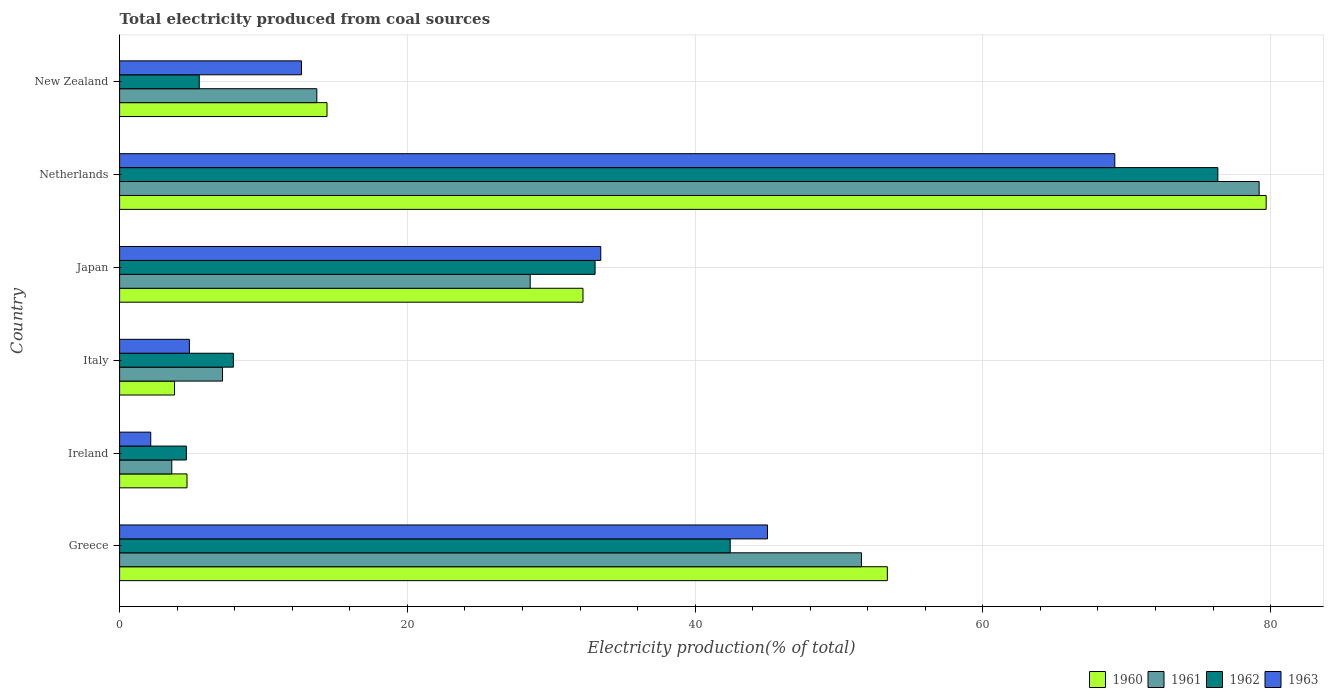Are the number of bars per tick equal to the number of legend labels?
Keep it short and to the point. Yes. How many bars are there on the 2nd tick from the top?
Your answer should be compact. 4. How many bars are there on the 5th tick from the bottom?
Offer a very short reply. 4. What is the total electricity produced in 1961 in New Zealand?
Offer a very short reply. 13.71. Across all countries, what is the maximum total electricity produced in 1963?
Give a very brief answer. 69.17. Across all countries, what is the minimum total electricity produced in 1962?
Give a very brief answer. 4.64. In which country was the total electricity produced in 1963 maximum?
Your response must be concise. Netherlands. In which country was the total electricity produced in 1963 minimum?
Make the answer very short. Ireland. What is the total total electricity produced in 1961 in the graph?
Provide a succinct answer. 183.8. What is the difference between the total electricity produced in 1963 in Italy and that in Japan?
Offer a terse response. -28.59. What is the difference between the total electricity produced in 1960 in Greece and the total electricity produced in 1963 in Netherlands?
Ensure brevity in your answer.  -15.81. What is the average total electricity produced in 1962 per country?
Your answer should be very brief. 28.32. What is the difference between the total electricity produced in 1962 and total electricity produced in 1960 in Japan?
Make the answer very short. 0.84. In how many countries, is the total electricity produced in 1961 greater than 8 %?
Keep it short and to the point. 4. What is the ratio of the total electricity produced in 1963 in Italy to that in New Zealand?
Keep it short and to the point. 0.38. Is the total electricity produced in 1962 in Italy less than that in New Zealand?
Ensure brevity in your answer.  No. Is the difference between the total electricity produced in 1962 in Greece and Japan greater than the difference between the total electricity produced in 1960 in Greece and Japan?
Provide a succinct answer. No. What is the difference between the highest and the second highest total electricity produced in 1961?
Your response must be concise. 27.64. What is the difference between the highest and the lowest total electricity produced in 1962?
Your response must be concise. 71.69. In how many countries, is the total electricity produced in 1963 greater than the average total electricity produced in 1963 taken over all countries?
Provide a succinct answer. 3. What does the 2nd bar from the top in New Zealand represents?
Offer a terse response. 1962. What does the 3rd bar from the bottom in Ireland represents?
Provide a succinct answer. 1962. How many bars are there?
Ensure brevity in your answer.  24. Are all the bars in the graph horizontal?
Your answer should be compact. Yes. How many countries are there in the graph?
Give a very brief answer. 6. Are the values on the major ticks of X-axis written in scientific E-notation?
Ensure brevity in your answer.  No. Does the graph contain any zero values?
Your response must be concise. No. Does the graph contain grids?
Your answer should be very brief. Yes. Where does the legend appear in the graph?
Your answer should be compact. Bottom right. How many legend labels are there?
Your answer should be compact. 4. How are the legend labels stacked?
Offer a very short reply. Horizontal. What is the title of the graph?
Make the answer very short. Total electricity produced from coal sources. Does "2010" appear as one of the legend labels in the graph?
Your response must be concise. No. What is the Electricity production(% of total) of 1960 in Greece?
Provide a short and direct response. 53.36. What is the Electricity production(% of total) of 1961 in Greece?
Your response must be concise. 51.56. What is the Electricity production(% of total) of 1962 in Greece?
Make the answer very short. 42.44. What is the Electricity production(% of total) of 1963 in Greece?
Offer a very short reply. 45.03. What is the Electricity production(% of total) of 1960 in Ireland?
Make the answer very short. 4.69. What is the Electricity production(% of total) in 1961 in Ireland?
Offer a very short reply. 3.63. What is the Electricity production(% of total) of 1962 in Ireland?
Offer a terse response. 4.64. What is the Electricity production(% of total) of 1963 in Ireland?
Keep it short and to the point. 2.16. What is the Electricity production(% of total) of 1960 in Italy?
Provide a succinct answer. 3.82. What is the Electricity production(% of total) of 1961 in Italy?
Provide a short and direct response. 7.15. What is the Electricity production(% of total) in 1962 in Italy?
Your answer should be compact. 7.91. What is the Electricity production(% of total) of 1963 in Italy?
Your response must be concise. 4.85. What is the Electricity production(% of total) of 1960 in Japan?
Your answer should be compact. 32.21. What is the Electricity production(% of total) in 1961 in Japan?
Your answer should be compact. 28.54. What is the Electricity production(% of total) in 1962 in Japan?
Offer a very short reply. 33.05. What is the Electricity production(% of total) in 1963 in Japan?
Offer a terse response. 33.44. What is the Electricity production(% of total) in 1960 in Netherlands?
Your answer should be very brief. 79.69. What is the Electricity production(% of total) of 1961 in Netherlands?
Provide a succinct answer. 79.2. What is the Electricity production(% of total) in 1962 in Netherlands?
Ensure brevity in your answer.  76.33. What is the Electricity production(% of total) in 1963 in Netherlands?
Ensure brevity in your answer.  69.17. What is the Electricity production(% of total) in 1960 in New Zealand?
Your answer should be very brief. 14.42. What is the Electricity production(% of total) of 1961 in New Zealand?
Keep it short and to the point. 13.71. What is the Electricity production(% of total) of 1962 in New Zealand?
Your answer should be compact. 5.54. What is the Electricity production(% of total) of 1963 in New Zealand?
Your answer should be compact. 12.64. Across all countries, what is the maximum Electricity production(% of total) of 1960?
Make the answer very short. 79.69. Across all countries, what is the maximum Electricity production(% of total) of 1961?
Provide a short and direct response. 79.2. Across all countries, what is the maximum Electricity production(% of total) in 1962?
Give a very brief answer. 76.33. Across all countries, what is the maximum Electricity production(% of total) of 1963?
Offer a very short reply. 69.17. Across all countries, what is the minimum Electricity production(% of total) of 1960?
Your response must be concise. 3.82. Across all countries, what is the minimum Electricity production(% of total) in 1961?
Ensure brevity in your answer.  3.63. Across all countries, what is the minimum Electricity production(% of total) in 1962?
Make the answer very short. 4.64. Across all countries, what is the minimum Electricity production(% of total) in 1963?
Your response must be concise. 2.16. What is the total Electricity production(% of total) in 1960 in the graph?
Your answer should be very brief. 188.18. What is the total Electricity production(% of total) in 1961 in the graph?
Your response must be concise. 183.8. What is the total Electricity production(% of total) of 1962 in the graph?
Offer a terse response. 169.91. What is the total Electricity production(% of total) in 1963 in the graph?
Provide a succinct answer. 167.3. What is the difference between the Electricity production(% of total) in 1960 in Greece and that in Ireland?
Provide a succinct answer. 48.68. What is the difference between the Electricity production(% of total) in 1961 in Greece and that in Ireland?
Your response must be concise. 47.93. What is the difference between the Electricity production(% of total) in 1962 in Greece and that in Ireland?
Your answer should be very brief. 37.8. What is the difference between the Electricity production(% of total) in 1963 in Greece and that in Ireland?
Keep it short and to the point. 42.87. What is the difference between the Electricity production(% of total) of 1960 in Greece and that in Italy?
Provide a succinct answer. 49.54. What is the difference between the Electricity production(% of total) in 1961 in Greece and that in Italy?
Ensure brevity in your answer.  44.41. What is the difference between the Electricity production(% of total) of 1962 in Greece and that in Italy?
Make the answer very short. 34.53. What is the difference between the Electricity production(% of total) of 1963 in Greece and that in Italy?
Provide a short and direct response. 40.18. What is the difference between the Electricity production(% of total) of 1960 in Greece and that in Japan?
Give a very brief answer. 21.15. What is the difference between the Electricity production(% of total) in 1961 in Greece and that in Japan?
Provide a succinct answer. 23.02. What is the difference between the Electricity production(% of total) of 1962 in Greece and that in Japan?
Give a very brief answer. 9.39. What is the difference between the Electricity production(% of total) of 1963 in Greece and that in Japan?
Provide a short and direct response. 11.59. What is the difference between the Electricity production(% of total) of 1960 in Greece and that in Netherlands?
Keep it short and to the point. -26.33. What is the difference between the Electricity production(% of total) in 1961 in Greece and that in Netherlands?
Offer a terse response. -27.64. What is the difference between the Electricity production(% of total) of 1962 in Greece and that in Netherlands?
Your answer should be compact. -33.89. What is the difference between the Electricity production(% of total) in 1963 in Greece and that in Netherlands?
Your response must be concise. -24.14. What is the difference between the Electricity production(% of total) in 1960 in Greece and that in New Zealand?
Provide a succinct answer. 38.95. What is the difference between the Electricity production(% of total) of 1961 in Greece and that in New Zealand?
Provide a short and direct response. 37.85. What is the difference between the Electricity production(% of total) of 1962 in Greece and that in New Zealand?
Offer a terse response. 36.9. What is the difference between the Electricity production(% of total) in 1963 in Greece and that in New Zealand?
Ensure brevity in your answer.  32.39. What is the difference between the Electricity production(% of total) of 1960 in Ireland and that in Italy?
Make the answer very short. 0.87. What is the difference between the Electricity production(% of total) in 1961 in Ireland and that in Italy?
Keep it short and to the point. -3.53. What is the difference between the Electricity production(% of total) in 1962 in Ireland and that in Italy?
Offer a terse response. -3.27. What is the difference between the Electricity production(% of total) of 1963 in Ireland and that in Italy?
Offer a very short reply. -2.69. What is the difference between the Electricity production(% of total) of 1960 in Ireland and that in Japan?
Keep it short and to the point. -27.52. What is the difference between the Electricity production(% of total) in 1961 in Ireland and that in Japan?
Your answer should be very brief. -24.91. What is the difference between the Electricity production(% of total) in 1962 in Ireland and that in Japan?
Your answer should be very brief. -28.41. What is the difference between the Electricity production(% of total) in 1963 in Ireland and that in Japan?
Ensure brevity in your answer.  -31.28. What is the difference between the Electricity production(% of total) in 1960 in Ireland and that in Netherlands?
Your answer should be compact. -75.01. What is the difference between the Electricity production(% of total) of 1961 in Ireland and that in Netherlands?
Provide a short and direct response. -75.58. What is the difference between the Electricity production(% of total) in 1962 in Ireland and that in Netherlands?
Your answer should be compact. -71.69. What is the difference between the Electricity production(% of total) in 1963 in Ireland and that in Netherlands?
Give a very brief answer. -67.01. What is the difference between the Electricity production(% of total) in 1960 in Ireland and that in New Zealand?
Keep it short and to the point. -9.73. What is the difference between the Electricity production(% of total) in 1961 in Ireland and that in New Zealand?
Ensure brevity in your answer.  -10.08. What is the difference between the Electricity production(% of total) of 1962 in Ireland and that in New Zealand?
Provide a succinct answer. -0.9. What is the difference between the Electricity production(% of total) in 1963 in Ireland and that in New Zealand?
Make the answer very short. -10.48. What is the difference between the Electricity production(% of total) in 1960 in Italy and that in Japan?
Provide a succinct answer. -28.39. What is the difference between the Electricity production(% of total) in 1961 in Italy and that in Japan?
Provide a succinct answer. -21.38. What is the difference between the Electricity production(% of total) in 1962 in Italy and that in Japan?
Provide a succinct answer. -25.14. What is the difference between the Electricity production(% of total) of 1963 in Italy and that in Japan?
Make the answer very short. -28.59. What is the difference between the Electricity production(% of total) of 1960 in Italy and that in Netherlands?
Provide a succinct answer. -75.87. What is the difference between the Electricity production(% of total) in 1961 in Italy and that in Netherlands?
Keep it short and to the point. -72.05. What is the difference between the Electricity production(% of total) in 1962 in Italy and that in Netherlands?
Offer a very short reply. -68.42. What is the difference between the Electricity production(% of total) in 1963 in Italy and that in Netherlands?
Offer a terse response. -64.32. What is the difference between the Electricity production(% of total) of 1960 in Italy and that in New Zealand?
Your answer should be very brief. -10.6. What is the difference between the Electricity production(% of total) of 1961 in Italy and that in New Zealand?
Provide a short and direct response. -6.55. What is the difference between the Electricity production(% of total) of 1962 in Italy and that in New Zealand?
Offer a very short reply. 2.37. What is the difference between the Electricity production(% of total) of 1963 in Italy and that in New Zealand?
Keep it short and to the point. -7.79. What is the difference between the Electricity production(% of total) of 1960 in Japan and that in Netherlands?
Provide a succinct answer. -47.48. What is the difference between the Electricity production(% of total) in 1961 in Japan and that in Netherlands?
Ensure brevity in your answer.  -50.67. What is the difference between the Electricity production(% of total) of 1962 in Japan and that in Netherlands?
Ensure brevity in your answer.  -43.28. What is the difference between the Electricity production(% of total) of 1963 in Japan and that in Netherlands?
Ensure brevity in your answer.  -35.73. What is the difference between the Electricity production(% of total) in 1960 in Japan and that in New Zealand?
Your answer should be compact. 17.79. What is the difference between the Electricity production(% of total) of 1961 in Japan and that in New Zealand?
Your answer should be compact. 14.83. What is the difference between the Electricity production(% of total) of 1962 in Japan and that in New Zealand?
Give a very brief answer. 27.51. What is the difference between the Electricity production(% of total) of 1963 in Japan and that in New Zealand?
Keep it short and to the point. 20.8. What is the difference between the Electricity production(% of total) of 1960 in Netherlands and that in New Zealand?
Offer a very short reply. 65.28. What is the difference between the Electricity production(% of total) of 1961 in Netherlands and that in New Zealand?
Provide a short and direct response. 65.5. What is the difference between the Electricity production(% of total) of 1962 in Netherlands and that in New Zealand?
Keep it short and to the point. 70.8. What is the difference between the Electricity production(% of total) in 1963 in Netherlands and that in New Zealand?
Ensure brevity in your answer.  56.53. What is the difference between the Electricity production(% of total) in 1960 in Greece and the Electricity production(% of total) in 1961 in Ireland?
Your answer should be very brief. 49.73. What is the difference between the Electricity production(% of total) of 1960 in Greece and the Electricity production(% of total) of 1962 in Ireland?
Provide a short and direct response. 48.72. What is the difference between the Electricity production(% of total) in 1960 in Greece and the Electricity production(% of total) in 1963 in Ireland?
Provide a short and direct response. 51.2. What is the difference between the Electricity production(% of total) of 1961 in Greece and the Electricity production(% of total) of 1962 in Ireland?
Give a very brief answer. 46.92. What is the difference between the Electricity production(% of total) in 1961 in Greece and the Electricity production(% of total) in 1963 in Ireland?
Ensure brevity in your answer.  49.4. What is the difference between the Electricity production(% of total) in 1962 in Greece and the Electricity production(% of total) in 1963 in Ireland?
Provide a short and direct response. 40.27. What is the difference between the Electricity production(% of total) in 1960 in Greece and the Electricity production(% of total) in 1961 in Italy?
Offer a very short reply. 46.21. What is the difference between the Electricity production(% of total) in 1960 in Greece and the Electricity production(% of total) in 1962 in Italy?
Your answer should be compact. 45.45. What is the difference between the Electricity production(% of total) in 1960 in Greece and the Electricity production(% of total) in 1963 in Italy?
Keep it short and to the point. 48.51. What is the difference between the Electricity production(% of total) in 1961 in Greece and the Electricity production(% of total) in 1962 in Italy?
Provide a short and direct response. 43.65. What is the difference between the Electricity production(% of total) of 1961 in Greece and the Electricity production(% of total) of 1963 in Italy?
Offer a terse response. 46.71. What is the difference between the Electricity production(% of total) in 1962 in Greece and the Electricity production(% of total) in 1963 in Italy?
Your response must be concise. 37.59. What is the difference between the Electricity production(% of total) in 1960 in Greece and the Electricity production(% of total) in 1961 in Japan?
Give a very brief answer. 24.82. What is the difference between the Electricity production(% of total) of 1960 in Greece and the Electricity production(% of total) of 1962 in Japan?
Your response must be concise. 20.31. What is the difference between the Electricity production(% of total) of 1960 in Greece and the Electricity production(% of total) of 1963 in Japan?
Give a very brief answer. 19.92. What is the difference between the Electricity production(% of total) in 1961 in Greece and the Electricity production(% of total) in 1962 in Japan?
Keep it short and to the point. 18.51. What is the difference between the Electricity production(% of total) of 1961 in Greece and the Electricity production(% of total) of 1963 in Japan?
Give a very brief answer. 18.12. What is the difference between the Electricity production(% of total) of 1962 in Greece and the Electricity production(% of total) of 1963 in Japan?
Give a very brief answer. 9. What is the difference between the Electricity production(% of total) of 1960 in Greece and the Electricity production(% of total) of 1961 in Netherlands?
Make the answer very short. -25.84. What is the difference between the Electricity production(% of total) in 1960 in Greece and the Electricity production(% of total) in 1962 in Netherlands?
Offer a very short reply. -22.97. What is the difference between the Electricity production(% of total) of 1960 in Greece and the Electricity production(% of total) of 1963 in Netherlands?
Make the answer very short. -15.81. What is the difference between the Electricity production(% of total) of 1961 in Greece and the Electricity production(% of total) of 1962 in Netherlands?
Make the answer very short. -24.77. What is the difference between the Electricity production(% of total) in 1961 in Greece and the Electricity production(% of total) in 1963 in Netherlands?
Make the answer very short. -17.61. What is the difference between the Electricity production(% of total) in 1962 in Greece and the Electricity production(% of total) in 1963 in Netherlands?
Keep it short and to the point. -26.73. What is the difference between the Electricity production(% of total) in 1960 in Greece and the Electricity production(% of total) in 1961 in New Zealand?
Provide a succinct answer. 39.65. What is the difference between the Electricity production(% of total) of 1960 in Greece and the Electricity production(% of total) of 1962 in New Zealand?
Ensure brevity in your answer.  47.83. What is the difference between the Electricity production(% of total) of 1960 in Greece and the Electricity production(% of total) of 1963 in New Zealand?
Keep it short and to the point. 40.72. What is the difference between the Electricity production(% of total) of 1961 in Greece and the Electricity production(% of total) of 1962 in New Zealand?
Your answer should be very brief. 46.03. What is the difference between the Electricity production(% of total) of 1961 in Greece and the Electricity production(% of total) of 1963 in New Zealand?
Keep it short and to the point. 38.92. What is the difference between the Electricity production(% of total) in 1962 in Greece and the Electricity production(% of total) in 1963 in New Zealand?
Give a very brief answer. 29.8. What is the difference between the Electricity production(% of total) of 1960 in Ireland and the Electricity production(% of total) of 1961 in Italy?
Give a very brief answer. -2.47. What is the difference between the Electricity production(% of total) of 1960 in Ireland and the Electricity production(% of total) of 1962 in Italy?
Provide a succinct answer. -3.22. What is the difference between the Electricity production(% of total) of 1960 in Ireland and the Electricity production(% of total) of 1963 in Italy?
Keep it short and to the point. -0.17. What is the difference between the Electricity production(% of total) in 1961 in Ireland and the Electricity production(% of total) in 1962 in Italy?
Give a very brief answer. -4.28. What is the difference between the Electricity production(% of total) of 1961 in Ireland and the Electricity production(% of total) of 1963 in Italy?
Keep it short and to the point. -1.22. What is the difference between the Electricity production(% of total) of 1962 in Ireland and the Electricity production(% of total) of 1963 in Italy?
Your answer should be compact. -0.21. What is the difference between the Electricity production(% of total) in 1960 in Ireland and the Electricity production(% of total) in 1961 in Japan?
Offer a terse response. -23.85. What is the difference between the Electricity production(% of total) of 1960 in Ireland and the Electricity production(% of total) of 1962 in Japan?
Make the answer very short. -28.36. What is the difference between the Electricity production(% of total) in 1960 in Ireland and the Electricity production(% of total) in 1963 in Japan?
Your response must be concise. -28.76. What is the difference between the Electricity production(% of total) of 1961 in Ireland and the Electricity production(% of total) of 1962 in Japan?
Provide a succinct answer. -29.42. What is the difference between the Electricity production(% of total) in 1961 in Ireland and the Electricity production(% of total) in 1963 in Japan?
Offer a very short reply. -29.82. What is the difference between the Electricity production(% of total) in 1962 in Ireland and the Electricity production(% of total) in 1963 in Japan?
Offer a terse response. -28.8. What is the difference between the Electricity production(% of total) in 1960 in Ireland and the Electricity production(% of total) in 1961 in Netherlands?
Ensure brevity in your answer.  -74.52. What is the difference between the Electricity production(% of total) in 1960 in Ireland and the Electricity production(% of total) in 1962 in Netherlands?
Give a very brief answer. -71.65. What is the difference between the Electricity production(% of total) in 1960 in Ireland and the Electricity production(% of total) in 1963 in Netherlands?
Give a very brief answer. -64.49. What is the difference between the Electricity production(% of total) of 1961 in Ireland and the Electricity production(% of total) of 1962 in Netherlands?
Your response must be concise. -72.71. What is the difference between the Electricity production(% of total) of 1961 in Ireland and the Electricity production(% of total) of 1963 in Netherlands?
Your answer should be compact. -65.54. What is the difference between the Electricity production(% of total) in 1962 in Ireland and the Electricity production(% of total) in 1963 in Netherlands?
Offer a very short reply. -64.53. What is the difference between the Electricity production(% of total) in 1960 in Ireland and the Electricity production(% of total) in 1961 in New Zealand?
Ensure brevity in your answer.  -9.02. What is the difference between the Electricity production(% of total) of 1960 in Ireland and the Electricity production(% of total) of 1962 in New Zealand?
Offer a terse response. -0.85. What is the difference between the Electricity production(% of total) of 1960 in Ireland and the Electricity production(% of total) of 1963 in New Zealand?
Provide a short and direct response. -7.95. What is the difference between the Electricity production(% of total) in 1961 in Ireland and the Electricity production(% of total) in 1962 in New Zealand?
Your response must be concise. -1.91. What is the difference between the Electricity production(% of total) of 1961 in Ireland and the Electricity production(% of total) of 1963 in New Zealand?
Your answer should be very brief. -9.01. What is the difference between the Electricity production(% of total) of 1962 in Ireland and the Electricity production(% of total) of 1963 in New Zealand?
Your response must be concise. -8. What is the difference between the Electricity production(% of total) in 1960 in Italy and the Electricity production(% of total) in 1961 in Japan?
Offer a terse response. -24.72. What is the difference between the Electricity production(% of total) of 1960 in Italy and the Electricity production(% of total) of 1962 in Japan?
Ensure brevity in your answer.  -29.23. What is the difference between the Electricity production(% of total) of 1960 in Italy and the Electricity production(% of total) of 1963 in Japan?
Your answer should be compact. -29.63. What is the difference between the Electricity production(% of total) in 1961 in Italy and the Electricity production(% of total) in 1962 in Japan?
Provide a short and direct response. -25.89. What is the difference between the Electricity production(% of total) in 1961 in Italy and the Electricity production(% of total) in 1963 in Japan?
Your response must be concise. -26.29. What is the difference between the Electricity production(% of total) of 1962 in Italy and the Electricity production(% of total) of 1963 in Japan?
Your response must be concise. -25.53. What is the difference between the Electricity production(% of total) of 1960 in Italy and the Electricity production(% of total) of 1961 in Netherlands?
Provide a succinct answer. -75.39. What is the difference between the Electricity production(% of total) of 1960 in Italy and the Electricity production(% of total) of 1962 in Netherlands?
Provide a short and direct response. -72.51. What is the difference between the Electricity production(% of total) in 1960 in Italy and the Electricity production(% of total) in 1963 in Netherlands?
Your response must be concise. -65.35. What is the difference between the Electricity production(% of total) in 1961 in Italy and the Electricity production(% of total) in 1962 in Netherlands?
Your response must be concise. -69.18. What is the difference between the Electricity production(% of total) in 1961 in Italy and the Electricity production(% of total) in 1963 in Netherlands?
Ensure brevity in your answer.  -62.02. What is the difference between the Electricity production(% of total) of 1962 in Italy and the Electricity production(% of total) of 1963 in Netherlands?
Keep it short and to the point. -61.26. What is the difference between the Electricity production(% of total) in 1960 in Italy and the Electricity production(% of total) in 1961 in New Zealand?
Ensure brevity in your answer.  -9.89. What is the difference between the Electricity production(% of total) of 1960 in Italy and the Electricity production(% of total) of 1962 in New Zealand?
Your response must be concise. -1.72. What is the difference between the Electricity production(% of total) in 1960 in Italy and the Electricity production(% of total) in 1963 in New Zealand?
Make the answer very short. -8.82. What is the difference between the Electricity production(% of total) in 1961 in Italy and the Electricity production(% of total) in 1962 in New Zealand?
Make the answer very short. 1.62. What is the difference between the Electricity production(% of total) in 1961 in Italy and the Electricity production(% of total) in 1963 in New Zealand?
Your response must be concise. -5.49. What is the difference between the Electricity production(% of total) in 1962 in Italy and the Electricity production(% of total) in 1963 in New Zealand?
Your answer should be compact. -4.73. What is the difference between the Electricity production(% of total) of 1960 in Japan and the Electricity production(% of total) of 1961 in Netherlands?
Provide a succinct answer. -47. What is the difference between the Electricity production(% of total) in 1960 in Japan and the Electricity production(% of total) in 1962 in Netherlands?
Make the answer very short. -44.13. What is the difference between the Electricity production(% of total) in 1960 in Japan and the Electricity production(% of total) in 1963 in Netherlands?
Keep it short and to the point. -36.96. What is the difference between the Electricity production(% of total) of 1961 in Japan and the Electricity production(% of total) of 1962 in Netherlands?
Offer a terse response. -47.79. What is the difference between the Electricity production(% of total) of 1961 in Japan and the Electricity production(% of total) of 1963 in Netherlands?
Keep it short and to the point. -40.63. What is the difference between the Electricity production(% of total) in 1962 in Japan and the Electricity production(% of total) in 1963 in Netherlands?
Keep it short and to the point. -36.12. What is the difference between the Electricity production(% of total) of 1960 in Japan and the Electricity production(% of total) of 1961 in New Zealand?
Make the answer very short. 18.5. What is the difference between the Electricity production(% of total) of 1960 in Japan and the Electricity production(% of total) of 1962 in New Zealand?
Your answer should be very brief. 26.67. What is the difference between the Electricity production(% of total) in 1960 in Japan and the Electricity production(% of total) in 1963 in New Zealand?
Your response must be concise. 19.57. What is the difference between the Electricity production(% of total) of 1961 in Japan and the Electricity production(% of total) of 1962 in New Zealand?
Your response must be concise. 23. What is the difference between the Electricity production(% of total) of 1961 in Japan and the Electricity production(% of total) of 1963 in New Zealand?
Ensure brevity in your answer.  15.9. What is the difference between the Electricity production(% of total) of 1962 in Japan and the Electricity production(% of total) of 1963 in New Zealand?
Make the answer very short. 20.41. What is the difference between the Electricity production(% of total) of 1960 in Netherlands and the Electricity production(% of total) of 1961 in New Zealand?
Offer a terse response. 65.98. What is the difference between the Electricity production(% of total) in 1960 in Netherlands and the Electricity production(% of total) in 1962 in New Zealand?
Give a very brief answer. 74.16. What is the difference between the Electricity production(% of total) in 1960 in Netherlands and the Electricity production(% of total) in 1963 in New Zealand?
Give a very brief answer. 67.05. What is the difference between the Electricity production(% of total) in 1961 in Netherlands and the Electricity production(% of total) in 1962 in New Zealand?
Your response must be concise. 73.67. What is the difference between the Electricity production(% of total) of 1961 in Netherlands and the Electricity production(% of total) of 1963 in New Zealand?
Ensure brevity in your answer.  66.56. What is the difference between the Electricity production(% of total) in 1962 in Netherlands and the Electricity production(% of total) in 1963 in New Zealand?
Your answer should be very brief. 63.69. What is the average Electricity production(% of total) in 1960 per country?
Keep it short and to the point. 31.36. What is the average Electricity production(% of total) in 1961 per country?
Keep it short and to the point. 30.63. What is the average Electricity production(% of total) of 1962 per country?
Make the answer very short. 28.32. What is the average Electricity production(% of total) of 1963 per country?
Offer a terse response. 27.88. What is the difference between the Electricity production(% of total) in 1960 and Electricity production(% of total) in 1961 in Greece?
Your response must be concise. 1.8. What is the difference between the Electricity production(% of total) of 1960 and Electricity production(% of total) of 1962 in Greece?
Your answer should be compact. 10.92. What is the difference between the Electricity production(% of total) in 1960 and Electricity production(% of total) in 1963 in Greece?
Offer a terse response. 8.33. What is the difference between the Electricity production(% of total) of 1961 and Electricity production(% of total) of 1962 in Greece?
Your response must be concise. 9.12. What is the difference between the Electricity production(% of total) in 1961 and Electricity production(% of total) in 1963 in Greece?
Your answer should be very brief. 6.53. What is the difference between the Electricity production(% of total) in 1962 and Electricity production(% of total) in 1963 in Greece?
Offer a terse response. -2.59. What is the difference between the Electricity production(% of total) in 1960 and Electricity production(% of total) in 1961 in Ireland?
Keep it short and to the point. 1.06. What is the difference between the Electricity production(% of total) in 1960 and Electricity production(% of total) in 1962 in Ireland?
Provide a succinct answer. 0.05. What is the difference between the Electricity production(% of total) in 1960 and Electricity production(% of total) in 1963 in Ireland?
Offer a very short reply. 2.52. What is the difference between the Electricity production(% of total) in 1961 and Electricity production(% of total) in 1962 in Ireland?
Offer a very short reply. -1.01. What is the difference between the Electricity production(% of total) in 1961 and Electricity production(% of total) in 1963 in Ireland?
Your response must be concise. 1.46. What is the difference between the Electricity production(% of total) in 1962 and Electricity production(% of total) in 1963 in Ireland?
Make the answer very short. 2.48. What is the difference between the Electricity production(% of total) in 1960 and Electricity production(% of total) in 1961 in Italy?
Your answer should be compact. -3.34. What is the difference between the Electricity production(% of total) in 1960 and Electricity production(% of total) in 1962 in Italy?
Keep it short and to the point. -4.09. What is the difference between the Electricity production(% of total) in 1960 and Electricity production(% of total) in 1963 in Italy?
Provide a short and direct response. -1.03. What is the difference between the Electricity production(% of total) of 1961 and Electricity production(% of total) of 1962 in Italy?
Keep it short and to the point. -0.75. What is the difference between the Electricity production(% of total) in 1961 and Electricity production(% of total) in 1963 in Italy?
Make the answer very short. 2.3. What is the difference between the Electricity production(% of total) of 1962 and Electricity production(% of total) of 1963 in Italy?
Your response must be concise. 3.06. What is the difference between the Electricity production(% of total) of 1960 and Electricity production(% of total) of 1961 in Japan?
Offer a very short reply. 3.67. What is the difference between the Electricity production(% of total) in 1960 and Electricity production(% of total) in 1962 in Japan?
Provide a short and direct response. -0.84. What is the difference between the Electricity production(% of total) of 1960 and Electricity production(% of total) of 1963 in Japan?
Make the answer very short. -1.24. What is the difference between the Electricity production(% of total) of 1961 and Electricity production(% of total) of 1962 in Japan?
Your answer should be very brief. -4.51. What is the difference between the Electricity production(% of total) of 1961 and Electricity production(% of total) of 1963 in Japan?
Keep it short and to the point. -4.9. What is the difference between the Electricity production(% of total) of 1962 and Electricity production(% of total) of 1963 in Japan?
Your response must be concise. -0.4. What is the difference between the Electricity production(% of total) of 1960 and Electricity production(% of total) of 1961 in Netherlands?
Provide a succinct answer. 0.49. What is the difference between the Electricity production(% of total) of 1960 and Electricity production(% of total) of 1962 in Netherlands?
Your answer should be compact. 3.36. What is the difference between the Electricity production(% of total) of 1960 and Electricity production(% of total) of 1963 in Netherlands?
Ensure brevity in your answer.  10.52. What is the difference between the Electricity production(% of total) of 1961 and Electricity production(% of total) of 1962 in Netherlands?
Keep it short and to the point. 2.87. What is the difference between the Electricity production(% of total) in 1961 and Electricity production(% of total) in 1963 in Netherlands?
Provide a short and direct response. 10.03. What is the difference between the Electricity production(% of total) of 1962 and Electricity production(% of total) of 1963 in Netherlands?
Give a very brief answer. 7.16. What is the difference between the Electricity production(% of total) of 1960 and Electricity production(% of total) of 1961 in New Zealand?
Ensure brevity in your answer.  0.71. What is the difference between the Electricity production(% of total) of 1960 and Electricity production(% of total) of 1962 in New Zealand?
Your answer should be very brief. 8.88. What is the difference between the Electricity production(% of total) in 1960 and Electricity production(% of total) in 1963 in New Zealand?
Ensure brevity in your answer.  1.78. What is the difference between the Electricity production(% of total) in 1961 and Electricity production(% of total) in 1962 in New Zealand?
Make the answer very short. 8.17. What is the difference between the Electricity production(% of total) of 1961 and Electricity production(% of total) of 1963 in New Zealand?
Your response must be concise. 1.07. What is the difference between the Electricity production(% of total) of 1962 and Electricity production(% of total) of 1963 in New Zealand?
Offer a terse response. -7.1. What is the ratio of the Electricity production(% of total) in 1960 in Greece to that in Ireland?
Give a very brief answer. 11.39. What is the ratio of the Electricity production(% of total) of 1961 in Greece to that in Ireland?
Provide a short and direct response. 14.21. What is the ratio of the Electricity production(% of total) in 1962 in Greece to that in Ireland?
Make the answer very short. 9.14. What is the ratio of the Electricity production(% of total) in 1963 in Greece to that in Ireland?
Ensure brevity in your answer.  20.8. What is the ratio of the Electricity production(% of total) in 1960 in Greece to that in Italy?
Provide a short and direct response. 13.97. What is the ratio of the Electricity production(% of total) in 1961 in Greece to that in Italy?
Offer a terse response. 7.21. What is the ratio of the Electricity production(% of total) of 1962 in Greece to that in Italy?
Your response must be concise. 5.37. What is the ratio of the Electricity production(% of total) in 1963 in Greece to that in Italy?
Your answer should be compact. 9.28. What is the ratio of the Electricity production(% of total) of 1960 in Greece to that in Japan?
Ensure brevity in your answer.  1.66. What is the ratio of the Electricity production(% of total) of 1961 in Greece to that in Japan?
Make the answer very short. 1.81. What is the ratio of the Electricity production(% of total) of 1962 in Greece to that in Japan?
Ensure brevity in your answer.  1.28. What is the ratio of the Electricity production(% of total) in 1963 in Greece to that in Japan?
Offer a terse response. 1.35. What is the ratio of the Electricity production(% of total) in 1960 in Greece to that in Netherlands?
Ensure brevity in your answer.  0.67. What is the ratio of the Electricity production(% of total) in 1961 in Greece to that in Netherlands?
Make the answer very short. 0.65. What is the ratio of the Electricity production(% of total) in 1962 in Greece to that in Netherlands?
Provide a short and direct response. 0.56. What is the ratio of the Electricity production(% of total) in 1963 in Greece to that in Netherlands?
Make the answer very short. 0.65. What is the ratio of the Electricity production(% of total) in 1960 in Greece to that in New Zealand?
Keep it short and to the point. 3.7. What is the ratio of the Electricity production(% of total) in 1961 in Greece to that in New Zealand?
Your response must be concise. 3.76. What is the ratio of the Electricity production(% of total) of 1962 in Greece to that in New Zealand?
Offer a terse response. 7.67. What is the ratio of the Electricity production(% of total) of 1963 in Greece to that in New Zealand?
Provide a succinct answer. 3.56. What is the ratio of the Electricity production(% of total) in 1960 in Ireland to that in Italy?
Your answer should be compact. 1.23. What is the ratio of the Electricity production(% of total) of 1961 in Ireland to that in Italy?
Give a very brief answer. 0.51. What is the ratio of the Electricity production(% of total) of 1962 in Ireland to that in Italy?
Ensure brevity in your answer.  0.59. What is the ratio of the Electricity production(% of total) of 1963 in Ireland to that in Italy?
Your answer should be very brief. 0.45. What is the ratio of the Electricity production(% of total) in 1960 in Ireland to that in Japan?
Provide a short and direct response. 0.15. What is the ratio of the Electricity production(% of total) of 1961 in Ireland to that in Japan?
Offer a terse response. 0.13. What is the ratio of the Electricity production(% of total) in 1962 in Ireland to that in Japan?
Offer a terse response. 0.14. What is the ratio of the Electricity production(% of total) in 1963 in Ireland to that in Japan?
Offer a terse response. 0.06. What is the ratio of the Electricity production(% of total) of 1960 in Ireland to that in Netherlands?
Your answer should be very brief. 0.06. What is the ratio of the Electricity production(% of total) in 1961 in Ireland to that in Netherlands?
Your response must be concise. 0.05. What is the ratio of the Electricity production(% of total) of 1962 in Ireland to that in Netherlands?
Make the answer very short. 0.06. What is the ratio of the Electricity production(% of total) in 1963 in Ireland to that in Netherlands?
Your answer should be very brief. 0.03. What is the ratio of the Electricity production(% of total) in 1960 in Ireland to that in New Zealand?
Give a very brief answer. 0.33. What is the ratio of the Electricity production(% of total) of 1961 in Ireland to that in New Zealand?
Make the answer very short. 0.26. What is the ratio of the Electricity production(% of total) of 1962 in Ireland to that in New Zealand?
Offer a terse response. 0.84. What is the ratio of the Electricity production(% of total) in 1963 in Ireland to that in New Zealand?
Make the answer very short. 0.17. What is the ratio of the Electricity production(% of total) in 1960 in Italy to that in Japan?
Your response must be concise. 0.12. What is the ratio of the Electricity production(% of total) of 1961 in Italy to that in Japan?
Provide a succinct answer. 0.25. What is the ratio of the Electricity production(% of total) of 1962 in Italy to that in Japan?
Provide a short and direct response. 0.24. What is the ratio of the Electricity production(% of total) of 1963 in Italy to that in Japan?
Your response must be concise. 0.15. What is the ratio of the Electricity production(% of total) in 1960 in Italy to that in Netherlands?
Keep it short and to the point. 0.05. What is the ratio of the Electricity production(% of total) of 1961 in Italy to that in Netherlands?
Give a very brief answer. 0.09. What is the ratio of the Electricity production(% of total) in 1962 in Italy to that in Netherlands?
Provide a succinct answer. 0.1. What is the ratio of the Electricity production(% of total) in 1963 in Italy to that in Netherlands?
Your response must be concise. 0.07. What is the ratio of the Electricity production(% of total) of 1960 in Italy to that in New Zealand?
Offer a terse response. 0.26. What is the ratio of the Electricity production(% of total) of 1961 in Italy to that in New Zealand?
Your answer should be compact. 0.52. What is the ratio of the Electricity production(% of total) in 1962 in Italy to that in New Zealand?
Your answer should be compact. 1.43. What is the ratio of the Electricity production(% of total) of 1963 in Italy to that in New Zealand?
Your answer should be compact. 0.38. What is the ratio of the Electricity production(% of total) of 1960 in Japan to that in Netherlands?
Keep it short and to the point. 0.4. What is the ratio of the Electricity production(% of total) in 1961 in Japan to that in Netherlands?
Keep it short and to the point. 0.36. What is the ratio of the Electricity production(% of total) of 1962 in Japan to that in Netherlands?
Give a very brief answer. 0.43. What is the ratio of the Electricity production(% of total) of 1963 in Japan to that in Netherlands?
Provide a short and direct response. 0.48. What is the ratio of the Electricity production(% of total) of 1960 in Japan to that in New Zealand?
Give a very brief answer. 2.23. What is the ratio of the Electricity production(% of total) in 1961 in Japan to that in New Zealand?
Give a very brief answer. 2.08. What is the ratio of the Electricity production(% of total) of 1962 in Japan to that in New Zealand?
Make the answer very short. 5.97. What is the ratio of the Electricity production(% of total) of 1963 in Japan to that in New Zealand?
Give a very brief answer. 2.65. What is the ratio of the Electricity production(% of total) in 1960 in Netherlands to that in New Zealand?
Provide a succinct answer. 5.53. What is the ratio of the Electricity production(% of total) of 1961 in Netherlands to that in New Zealand?
Give a very brief answer. 5.78. What is the ratio of the Electricity production(% of total) of 1962 in Netherlands to that in New Zealand?
Make the answer very short. 13.79. What is the ratio of the Electricity production(% of total) in 1963 in Netherlands to that in New Zealand?
Make the answer very short. 5.47. What is the difference between the highest and the second highest Electricity production(% of total) of 1960?
Keep it short and to the point. 26.33. What is the difference between the highest and the second highest Electricity production(% of total) in 1961?
Your answer should be compact. 27.64. What is the difference between the highest and the second highest Electricity production(% of total) in 1962?
Offer a terse response. 33.89. What is the difference between the highest and the second highest Electricity production(% of total) of 1963?
Make the answer very short. 24.14. What is the difference between the highest and the lowest Electricity production(% of total) in 1960?
Offer a very short reply. 75.87. What is the difference between the highest and the lowest Electricity production(% of total) in 1961?
Provide a succinct answer. 75.58. What is the difference between the highest and the lowest Electricity production(% of total) in 1962?
Your answer should be compact. 71.69. What is the difference between the highest and the lowest Electricity production(% of total) in 1963?
Your answer should be very brief. 67.01. 